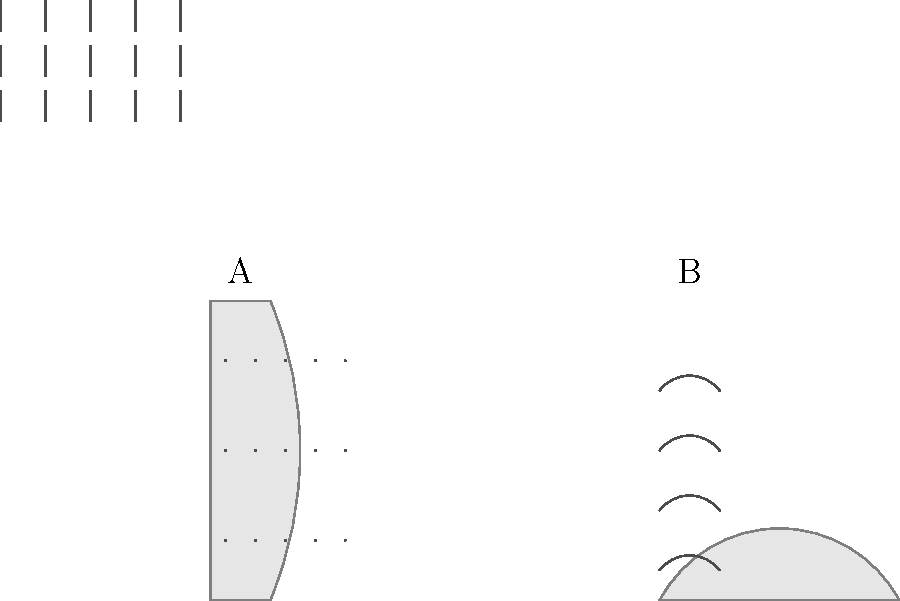Analyze the glaze patterns on the two pottery pieces shown above. Which piece is more likely to be from the Ming Dynasty, known for its intricate and densely packed decorations? To answer this question, we need to consider the characteristics of Ming Dynasty ceramics and compare them to the patterns shown in the image:

1. Ming Dynasty ceramics are known for their intricate and densely packed decorations.

2. Piece A (the vase):
   - Features a dot pattern
   - The dots are evenly distributed
   - The pattern is relatively simple and not densely packed

3. Piece B (the bowl):
   - Combines two different patterns: waves and lines
   - The patterns cover most of the visible surface
   - The combination of patterns creates a more intricate design
   - The decorations are more densely packed compared to Piece A

4. Comparing the two pieces:
   - Piece B has a more complex and densely packed decoration
   - Piece B combines multiple patterns, creating more visual interest
   - Piece B's decoration style is more consistent with the characteristics of Ming Dynasty ceramics

5. Conclusion:
   Based on the characteristics of Ming Dynasty ceramics and the analysis of the two pieces, Piece B is more likely to be from the Ming Dynasty due to its more intricate and densely packed decorations.
Answer: Piece B 